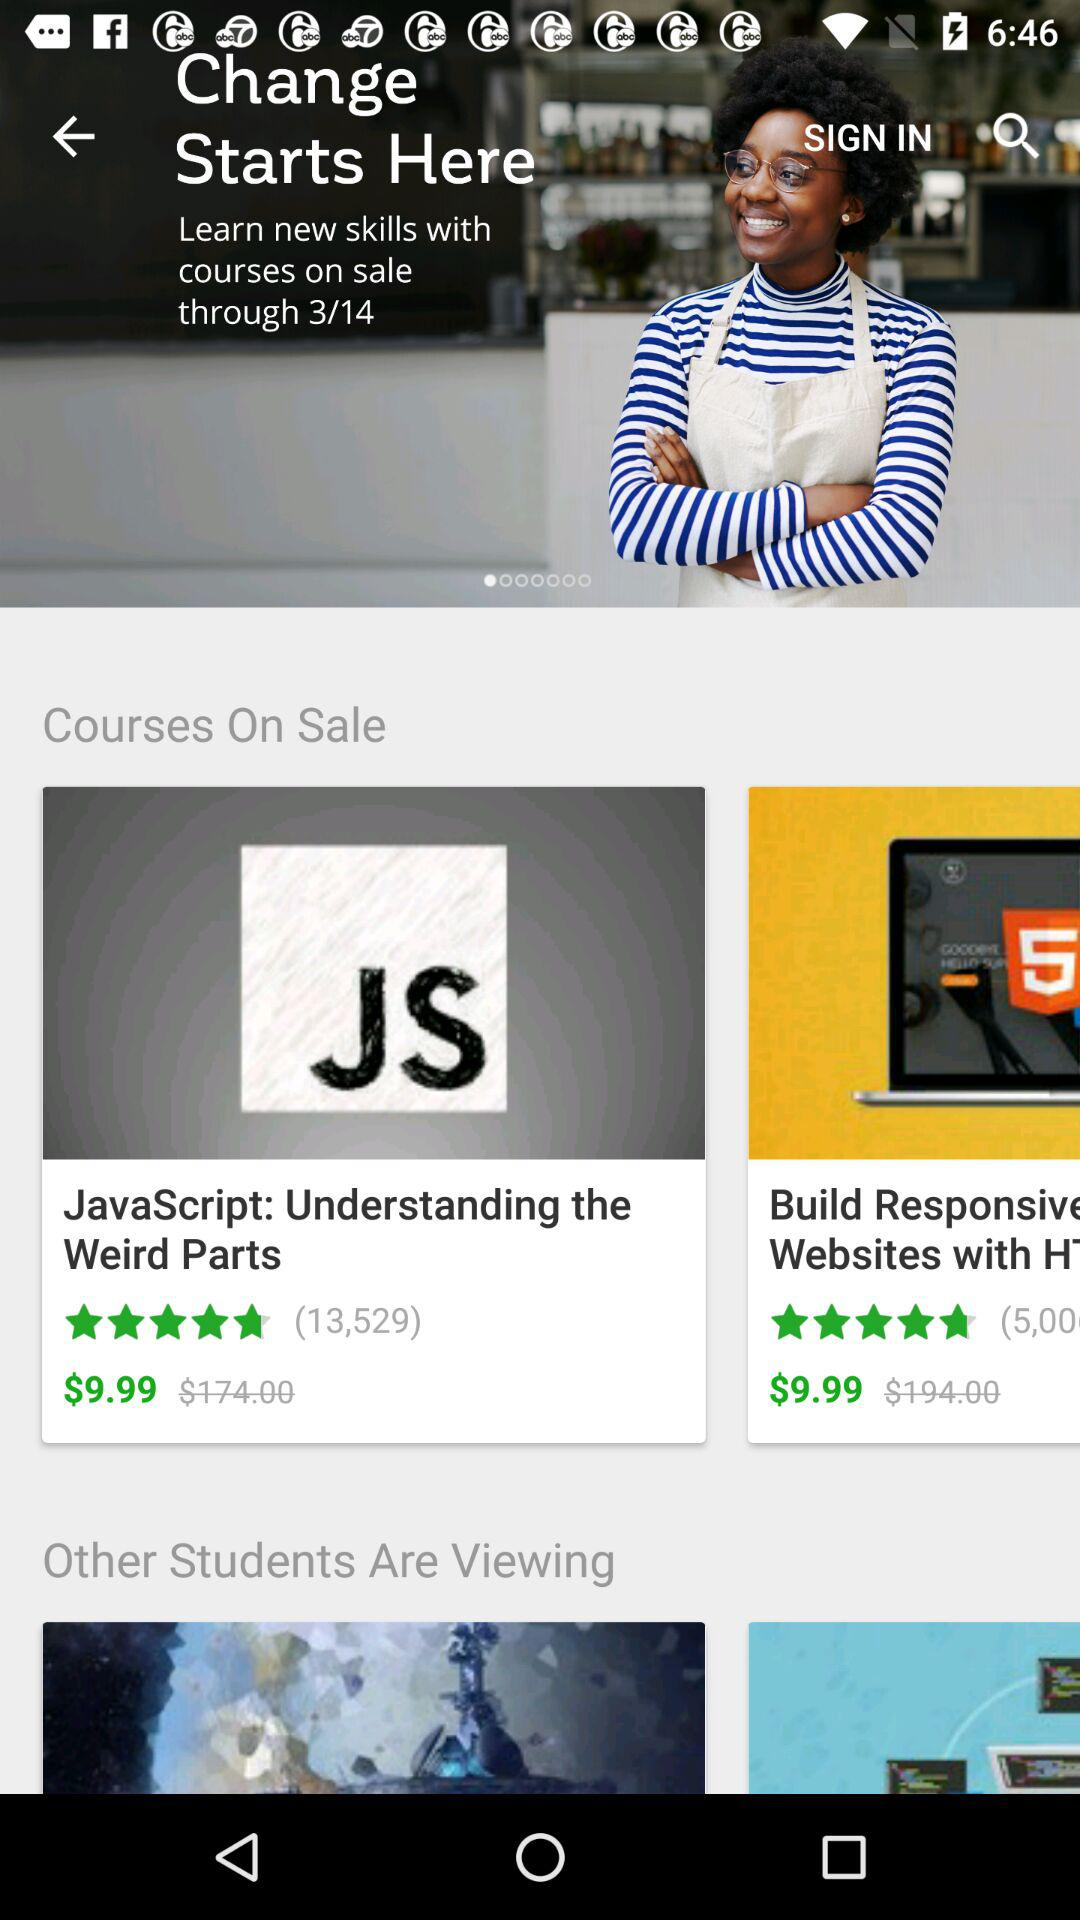How many courses are on sale?
Answer the question using a single word or phrase. 2 